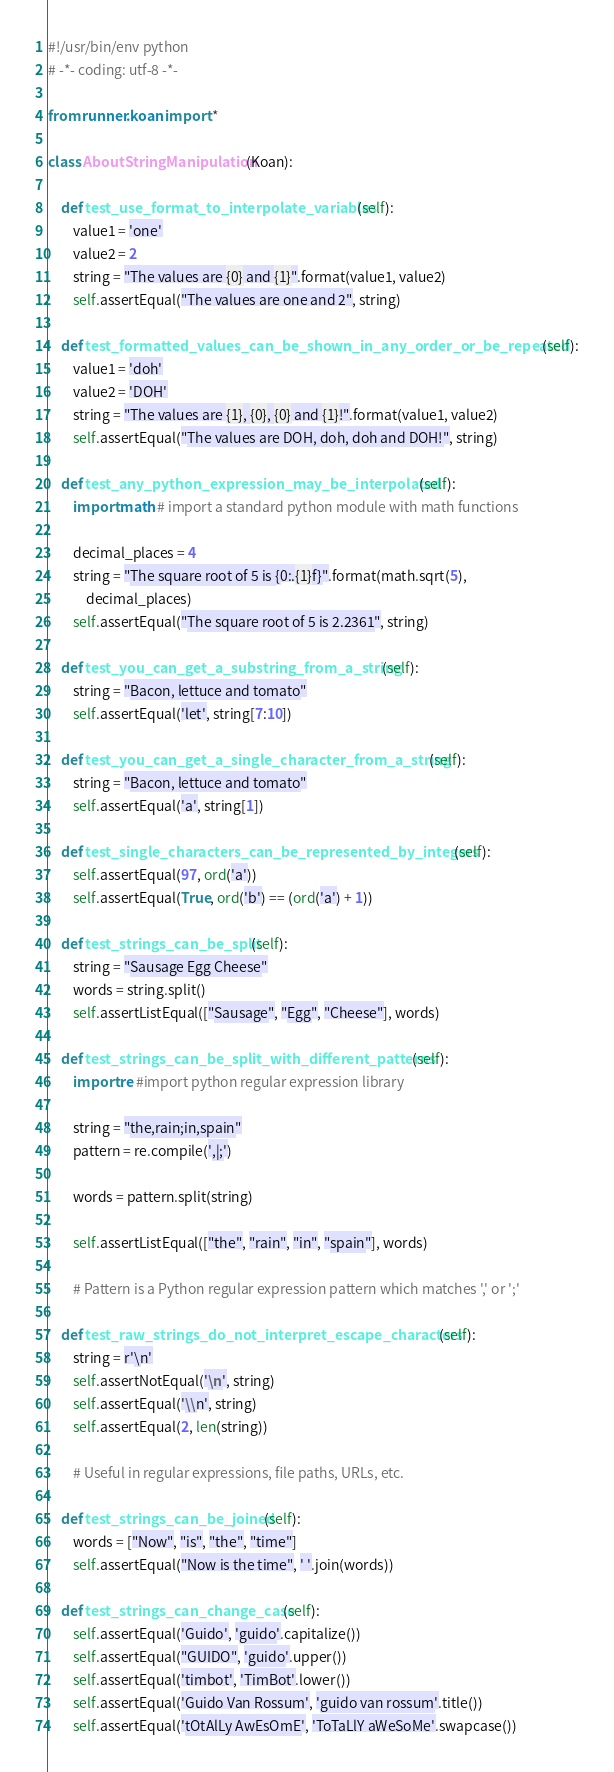<code> <loc_0><loc_0><loc_500><loc_500><_Python_>#!/usr/bin/env python
# -*- coding: utf-8 -*-

from runner.koan import *

class AboutStringManipulation(Koan):

    def test_use_format_to_interpolate_variables(self):
        value1 = 'one'
        value2 = 2
        string = "The values are {0} and {1}".format(value1, value2)
        self.assertEqual("The values are one and 2", string)

    def test_formatted_values_can_be_shown_in_any_order_or_be_repeated(self):
        value1 = 'doh'
        value2 = 'DOH'
        string = "The values are {1}, {0}, {0} and {1}!".format(value1, value2)
        self.assertEqual("The values are DOH, doh, doh and DOH!", string)

    def test_any_python_expression_may_be_interpolated(self):
        import math # import a standard python module with math functions

        decimal_places = 4
        string = "The square root of 5 is {0:.{1}f}".format(math.sqrt(5),
            decimal_places)
        self.assertEqual("The square root of 5 is 2.2361", string)

    def test_you_can_get_a_substring_from_a_string(self):
        string = "Bacon, lettuce and tomato"
        self.assertEqual('let', string[7:10])

    def test_you_can_get_a_single_character_from_a_string(self):
        string = "Bacon, lettuce and tomato"
        self.assertEqual('a', string[1])

    def test_single_characters_can_be_represented_by_integers(self):
        self.assertEqual(97, ord('a'))
        self.assertEqual(True, ord('b') == (ord('a') + 1))

    def test_strings_can_be_split(self):
        string = "Sausage Egg Cheese"
        words = string.split()
        self.assertListEqual(["Sausage", "Egg", "Cheese"], words)

    def test_strings_can_be_split_with_different_patterns(self):
        import re #import python regular expression library

        string = "the,rain;in,spain"
        pattern = re.compile(',|;')

        words = pattern.split(string)

        self.assertListEqual(["the", "rain", "in", "spain"], words)

        # Pattern is a Python regular expression pattern which matches ',' or ';'

    def test_raw_strings_do_not_interpret_escape_characters(self):
        string = r'\n'
        self.assertNotEqual('\n', string)
        self.assertEqual('\\n', string)
        self.assertEqual(2, len(string))

        # Useful in regular expressions, file paths, URLs, etc.

    def test_strings_can_be_joined(self):
        words = ["Now", "is", "the", "time"]
        self.assertEqual("Now is the time", ' '.join(words))

    def test_strings_can_change_case(self):
        self.assertEqual('Guido', 'guido'.capitalize())
        self.assertEqual("GUIDO", 'guido'.upper())
        self.assertEqual('timbot', 'TimBot'.lower())
        self.assertEqual('Guido Van Rossum', 'guido van rossum'.title())
        self.assertEqual('tOtAlLy AwEsOmE', 'ToTaLlY aWeSoMe'.swapcase())
</code> 